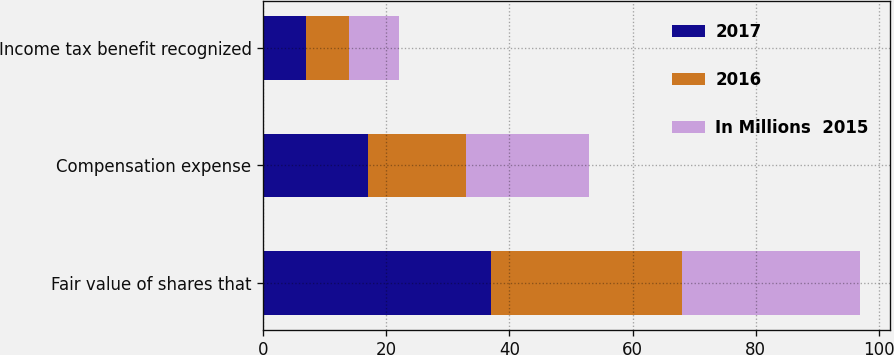Convert chart to OTSL. <chart><loc_0><loc_0><loc_500><loc_500><stacked_bar_chart><ecel><fcel>Fair value of shares that<fcel>Compensation expense<fcel>Income tax benefit recognized<nl><fcel>2017<fcel>37<fcel>17<fcel>7<nl><fcel>2016<fcel>31<fcel>16<fcel>7<nl><fcel>In Millions  2015<fcel>29<fcel>20<fcel>8<nl></chart> 